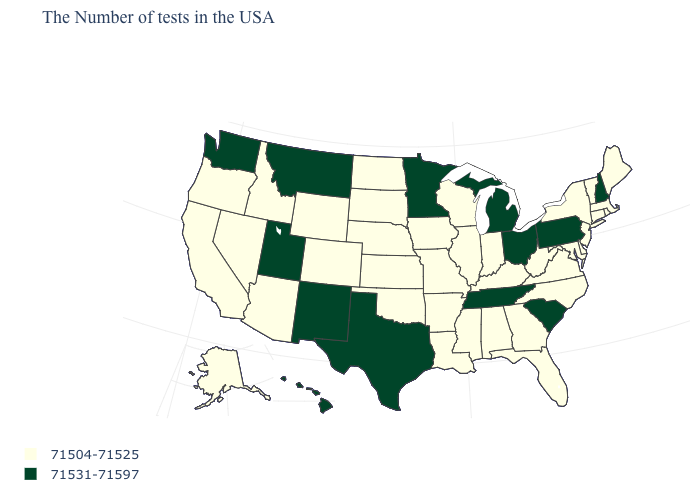What is the value of Maryland?
Short answer required. 71504-71525. What is the value of Pennsylvania?
Keep it brief. 71531-71597. Among the states that border North Dakota , which have the lowest value?
Keep it brief. South Dakota. What is the highest value in the West ?
Give a very brief answer. 71531-71597. Name the states that have a value in the range 71531-71597?
Short answer required. New Hampshire, Pennsylvania, South Carolina, Ohio, Michigan, Tennessee, Minnesota, Texas, New Mexico, Utah, Montana, Washington, Hawaii. Is the legend a continuous bar?
Be succinct. No. Does New Mexico have the same value as Utah?
Give a very brief answer. Yes. Does Montana have the lowest value in the USA?
Write a very short answer. No. Name the states that have a value in the range 71504-71525?
Write a very short answer. Maine, Massachusetts, Rhode Island, Vermont, Connecticut, New York, New Jersey, Delaware, Maryland, Virginia, North Carolina, West Virginia, Florida, Georgia, Kentucky, Indiana, Alabama, Wisconsin, Illinois, Mississippi, Louisiana, Missouri, Arkansas, Iowa, Kansas, Nebraska, Oklahoma, South Dakota, North Dakota, Wyoming, Colorado, Arizona, Idaho, Nevada, California, Oregon, Alaska. Is the legend a continuous bar?
Concise answer only. No. What is the value of Texas?
Short answer required. 71531-71597. Among the states that border Texas , which have the lowest value?
Concise answer only. Louisiana, Arkansas, Oklahoma. Name the states that have a value in the range 71531-71597?
Quick response, please. New Hampshire, Pennsylvania, South Carolina, Ohio, Michigan, Tennessee, Minnesota, Texas, New Mexico, Utah, Montana, Washington, Hawaii. What is the value of Wisconsin?
Short answer required. 71504-71525. What is the highest value in the USA?
Concise answer only. 71531-71597. 